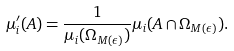Convert formula to latex. <formula><loc_0><loc_0><loc_500><loc_500>\mu _ { i } ^ { \prime } ( A ) = \frac { 1 } { \mu _ { i } ( \Omega _ { M ( \epsilon ) } ) } \mu _ { i } ( A \cap \Omega _ { M ( \epsilon ) } ) .</formula> 